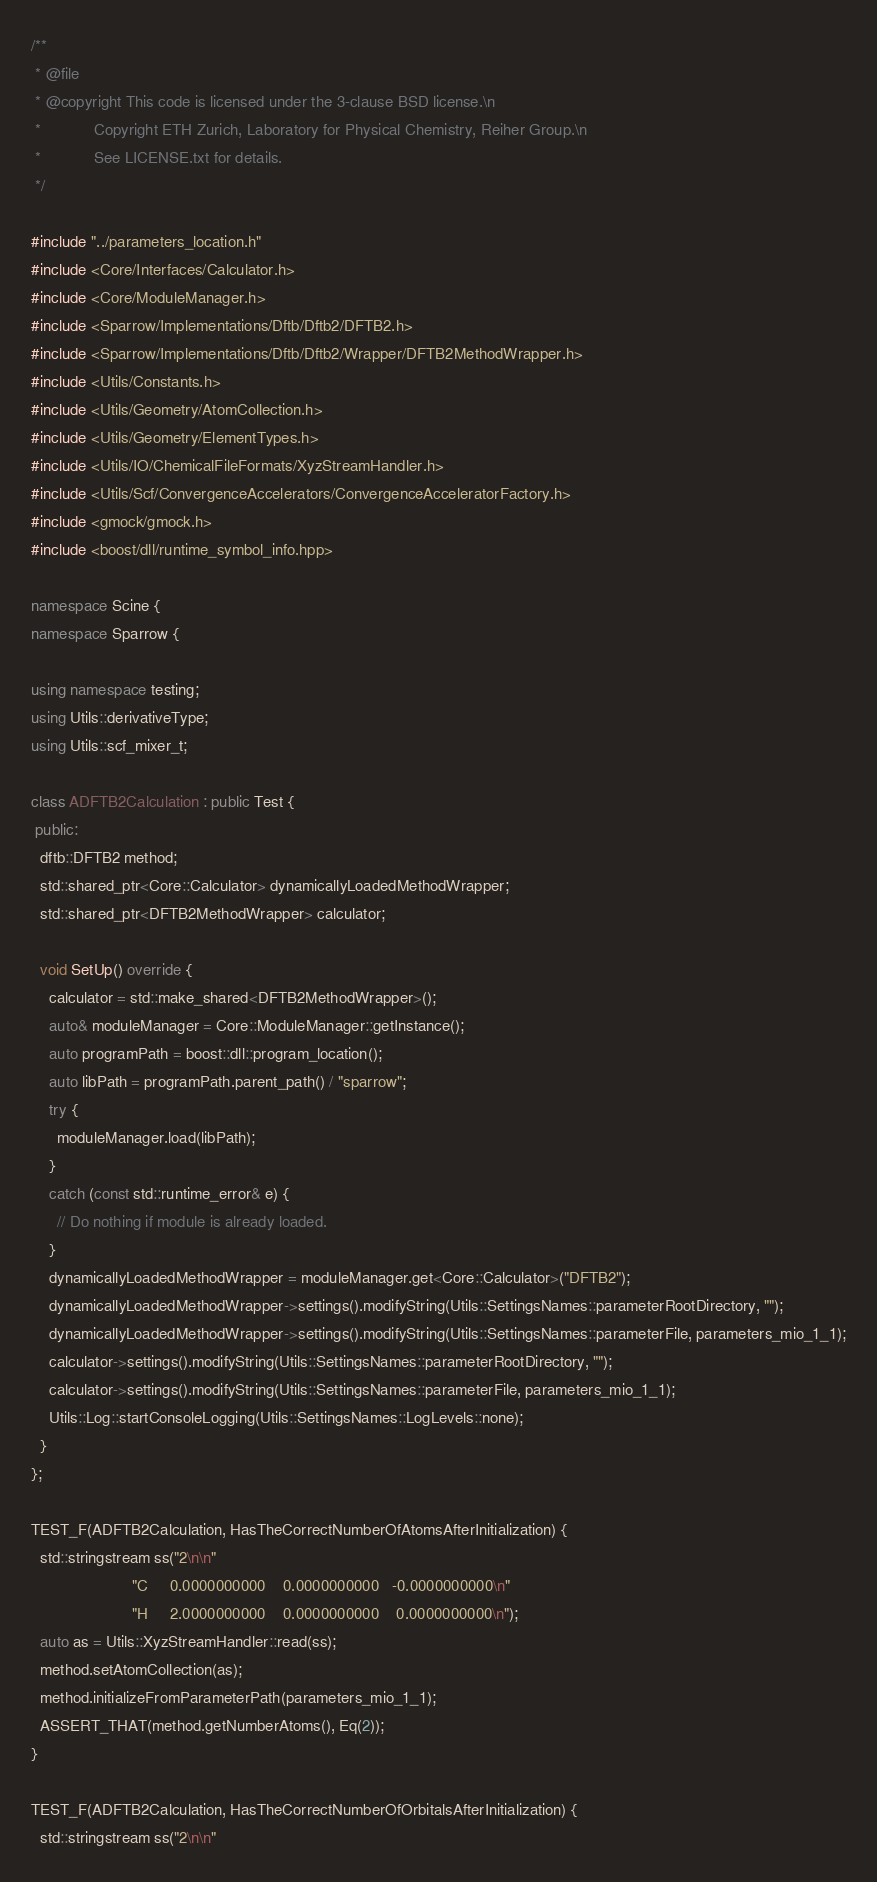Convert code to text. <code><loc_0><loc_0><loc_500><loc_500><_C++_>/**
 * @file
 * @copyright This code is licensed under the 3-clause BSD license.\n
 *            Copyright ETH Zurich, Laboratory for Physical Chemistry, Reiher Group.\n
 *            See LICENSE.txt for details.
 */

#include "../parameters_location.h"
#include <Core/Interfaces/Calculator.h>
#include <Core/ModuleManager.h>
#include <Sparrow/Implementations/Dftb/Dftb2/DFTB2.h>
#include <Sparrow/Implementations/Dftb/Dftb2/Wrapper/DFTB2MethodWrapper.h>
#include <Utils/Constants.h>
#include <Utils/Geometry/AtomCollection.h>
#include <Utils/Geometry/ElementTypes.h>
#include <Utils/IO/ChemicalFileFormats/XyzStreamHandler.h>
#include <Utils/Scf/ConvergenceAccelerators/ConvergenceAcceleratorFactory.h>
#include <gmock/gmock.h>
#include <boost/dll/runtime_symbol_info.hpp>

namespace Scine {
namespace Sparrow {

using namespace testing;
using Utils::derivativeType;
using Utils::scf_mixer_t;

class ADFTB2Calculation : public Test {
 public:
  dftb::DFTB2 method;
  std::shared_ptr<Core::Calculator> dynamicallyLoadedMethodWrapper;
  std::shared_ptr<DFTB2MethodWrapper> calculator;

  void SetUp() override {
    calculator = std::make_shared<DFTB2MethodWrapper>();
    auto& moduleManager = Core::ModuleManager::getInstance();
    auto programPath = boost::dll::program_location();
    auto libPath = programPath.parent_path() / "sparrow";
    try {
      moduleManager.load(libPath);
    }
    catch (const std::runtime_error& e) {
      // Do nothing if module is already loaded.
    }
    dynamicallyLoadedMethodWrapper = moduleManager.get<Core::Calculator>("DFTB2");
    dynamicallyLoadedMethodWrapper->settings().modifyString(Utils::SettingsNames::parameterRootDirectory, "");
    dynamicallyLoadedMethodWrapper->settings().modifyString(Utils::SettingsNames::parameterFile, parameters_mio_1_1);
    calculator->settings().modifyString(Utils::SettingsNames::parameterRootDirectory, "");
    calculator->settings().modifyString(Utils::SettingsNames::parameterFile, parameters_mio_1_1);
    Utils::Log::startConsoleLogging(Utils::SettingsNames::LogLevels::none);
  }
};

TEST_F(ADFTB2Calculation, HasTheCorrectNumberOfAtomsAfterInitialization) {
  std::stringstream ss("2\n\n"
                       "C     0.0000000000    0.0000000000   -0.0000000000\n"
                       "H     2.0000000000    0.0000000000    0.0000000000\n");
  auto as = Utils::XyzStreamHandler::read(ss);
  method.setAtomCollection(as);
  method.initializeFromParameterPath(parameters_mio_1_1);
  ASSERT_THAT(method.getNumberAtoms(), Eq(2));
}

TEST_F(ADFTB2Calculation, HasTheCorrectNumberOfOrbitalsAfterInitialization) {
  std::stringstream ss("2\n\n"</code> 